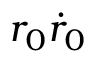Convert formula to latex. <formula><loc_0><loc_0><loc_500><loc_500>r _ { 0 } \dot { r } _ { 0 }</formula> 